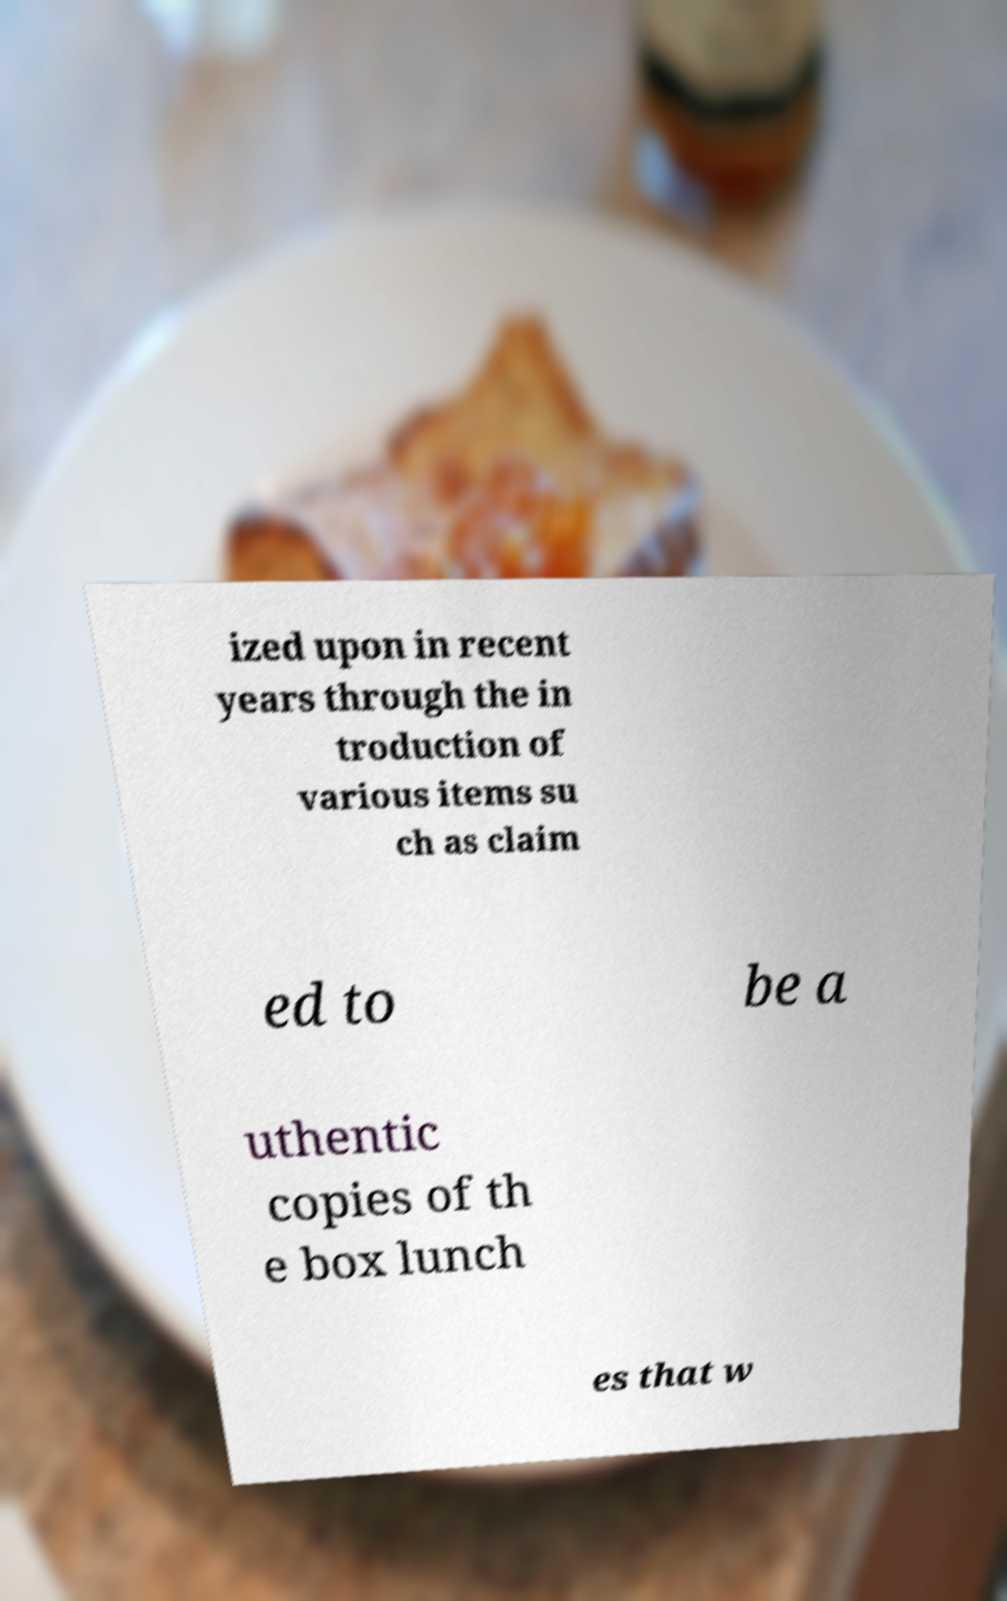Could you assist in decoding the text presented in this image and type it out clearly? ized upon in recent years through the in troduction of various items su ch as claim ed to be a uthentic copies of th e box lunch es that w 